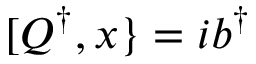Convert formula to latex. <formula><loc_0><loc_0><loc_500><loc_500>[ Q ^ { \dagger } , x \} = i b ^ { \dagger }</formula> 